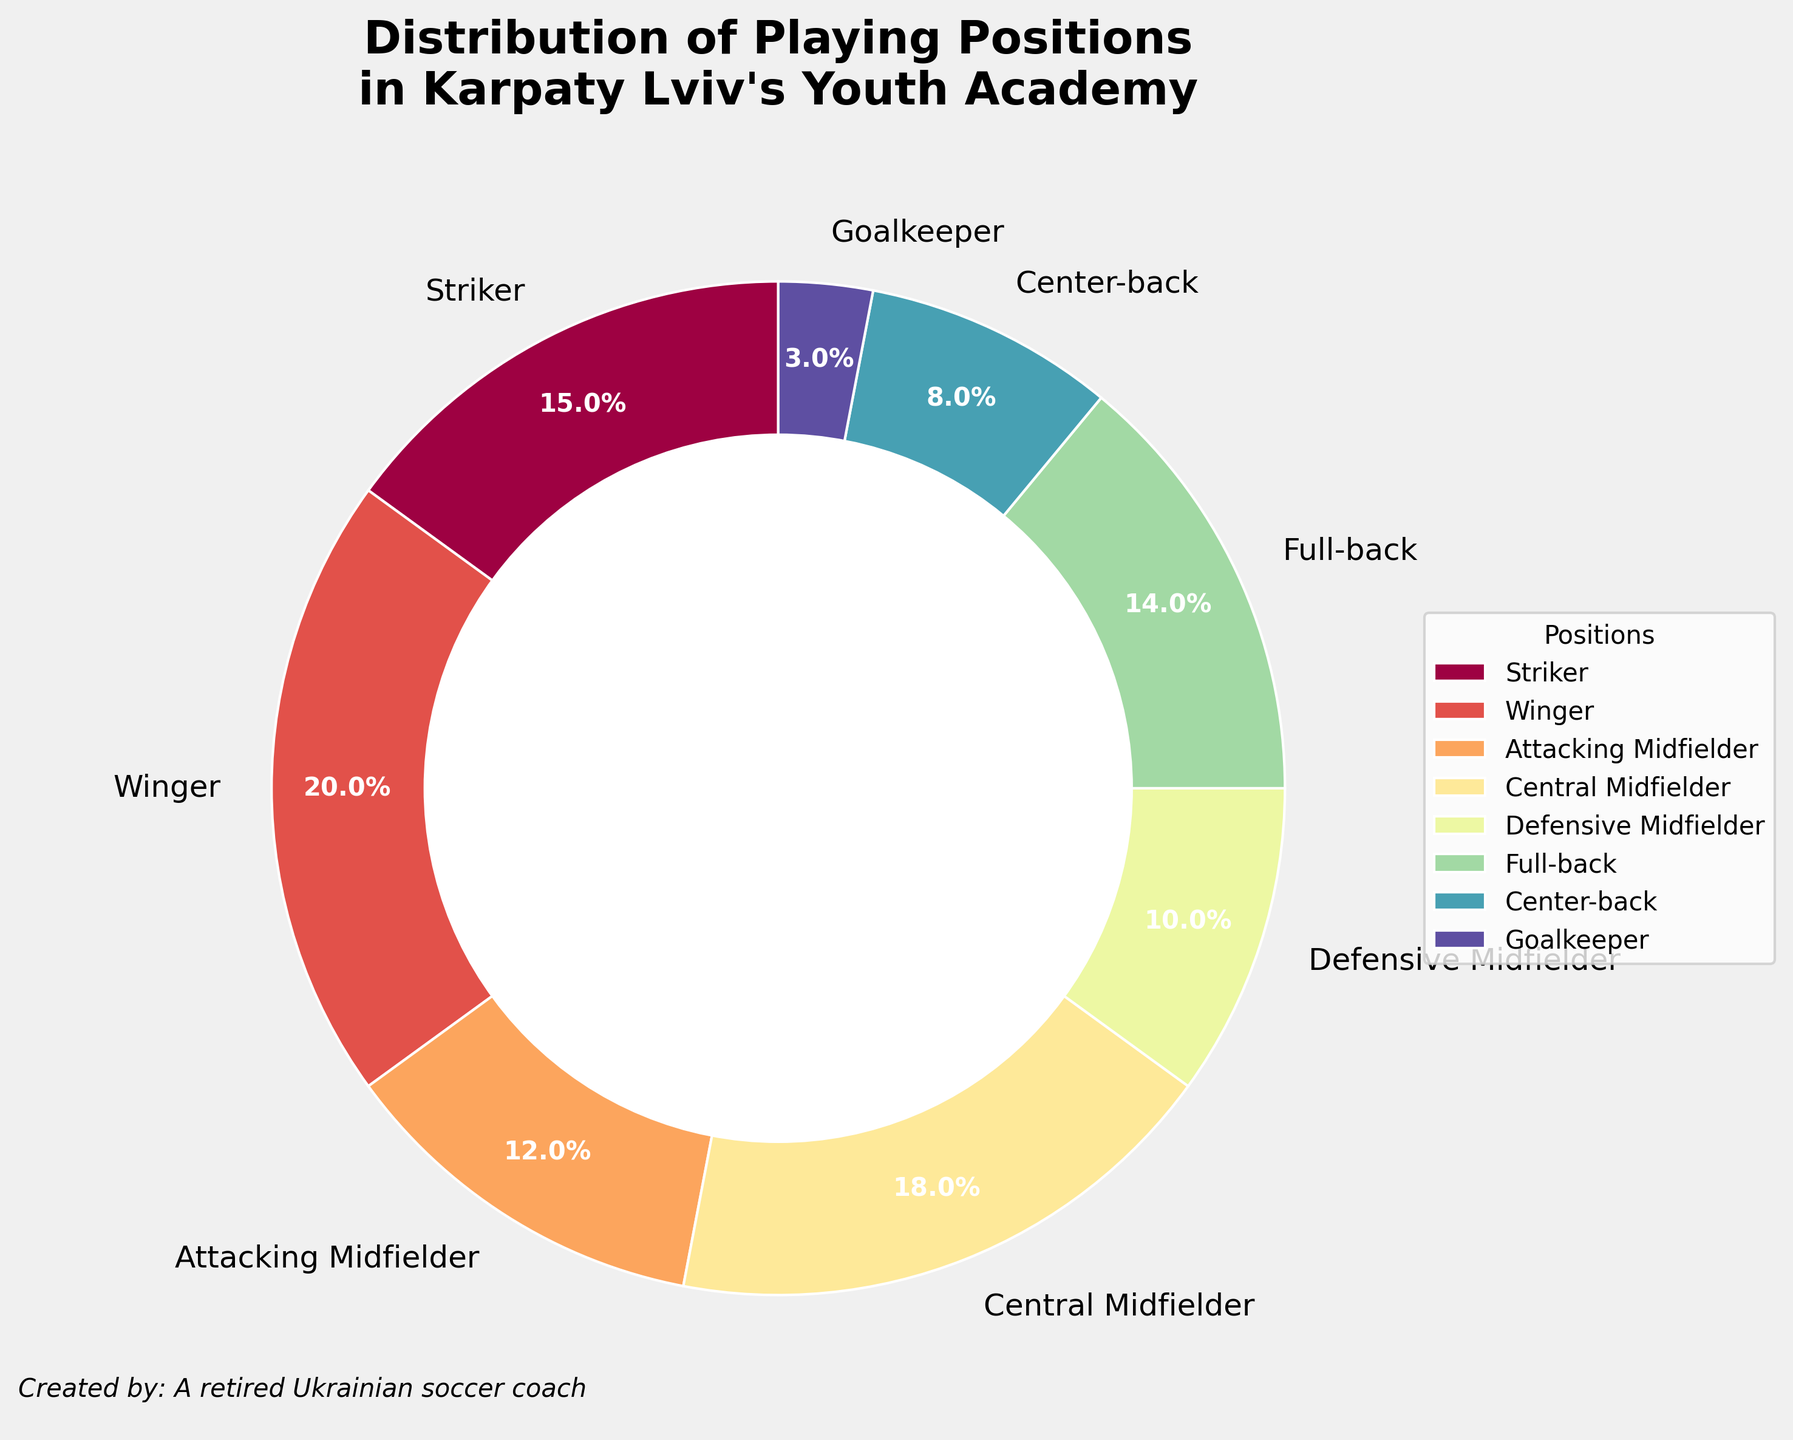What's the most common playing position in Karpaty Lviv's youth academy? By looking at the chart, the Winger position represents the largest section in the pie chart, which signifies it is the most common playing position.
Answer: Winger Which position has a larger proportion: Striker or Goalkeeper? Comparing the two sections in the pie chart, the Striker position has a significantly larger section than the Goalkeeper.
Answer: Striker What is the combined percentage for all midfielder positions (Attacking Midfielder, Central Midfielder, and Defensive Midfielder)? Summing up the percentages of Attacking Midfielder (12%), Central Midfielder (18%), and Defensive Midfielder (10%): 12 + 18 + 10 = 40.
Answer: 40% How does the percentage of Full-backs compare to the percentage of Center-backs? By looking at the relative sizes of the sections in the pie chart, the percentage of Full-backs (14%) is nearly twice that of Center-backs (8%).
Answer: Full-backs have a higher percentage What's the percentage difference between the most and the least common positions? The most common position is Winger (20%) and the least common is Goalkeeper (3%). The difference is 20 – 3 = 17.
Answer: 17% Which positions make up more than 10% of the dataset? The pie chart shows that Winger (20%), Striker (15%), Central Midfielder (18%), Full-back (14%), and Attacking Midfielder (12%) all have percentages higher than 10%.
Answer: Winger, Striker, Central Midfielder, Full-back, Attacking Midfielder What fraction of positions have a percentage lower than 15%? The positions with percentages lower than 15% are Attacking Midfielder (12%), Defensive Midfielder (10%), Full-back (14%), Center-back (8%), and Goalkeeper (3%). There are 8 positions in total, so 5/8 is the fraction.
Answer: 5/8 If we were to group defensive positions together (Defensive Midfielder, Full-back, and Center-back), what would their combined percentage be? Adding the percentages of Defensive Midfielder (10%), Full-back (14%), and Center-back (8%): 10 + 14 + 8 = 32.
Answer: 32% Is the sum of the percentages of all midfielder positions greater than the sum of all defender positions? All midfielder positions together (Attacking, Central, Defensive) sum to 12 + 18 + 10 = 40. All defender positions together (Full-back, Center-back) sum to 14 + 8 = 22. Since 40 > 22, the sum of midfielders is greater.
Answer: Yes Given this distribution, would you say the academy has more offensive or defensive emphasis? Summing all offensive players (Striker, Winger, and Attacking Midfielder): 15 + 20 + 12 = 47. Summing all defensive players (Defensive Midfielder, Full-back, and Center-back): 10 + 14 + 8 = 32. Since 47 > 32, the academy has more emphasis on offensive positions.
Answer: Offensive 